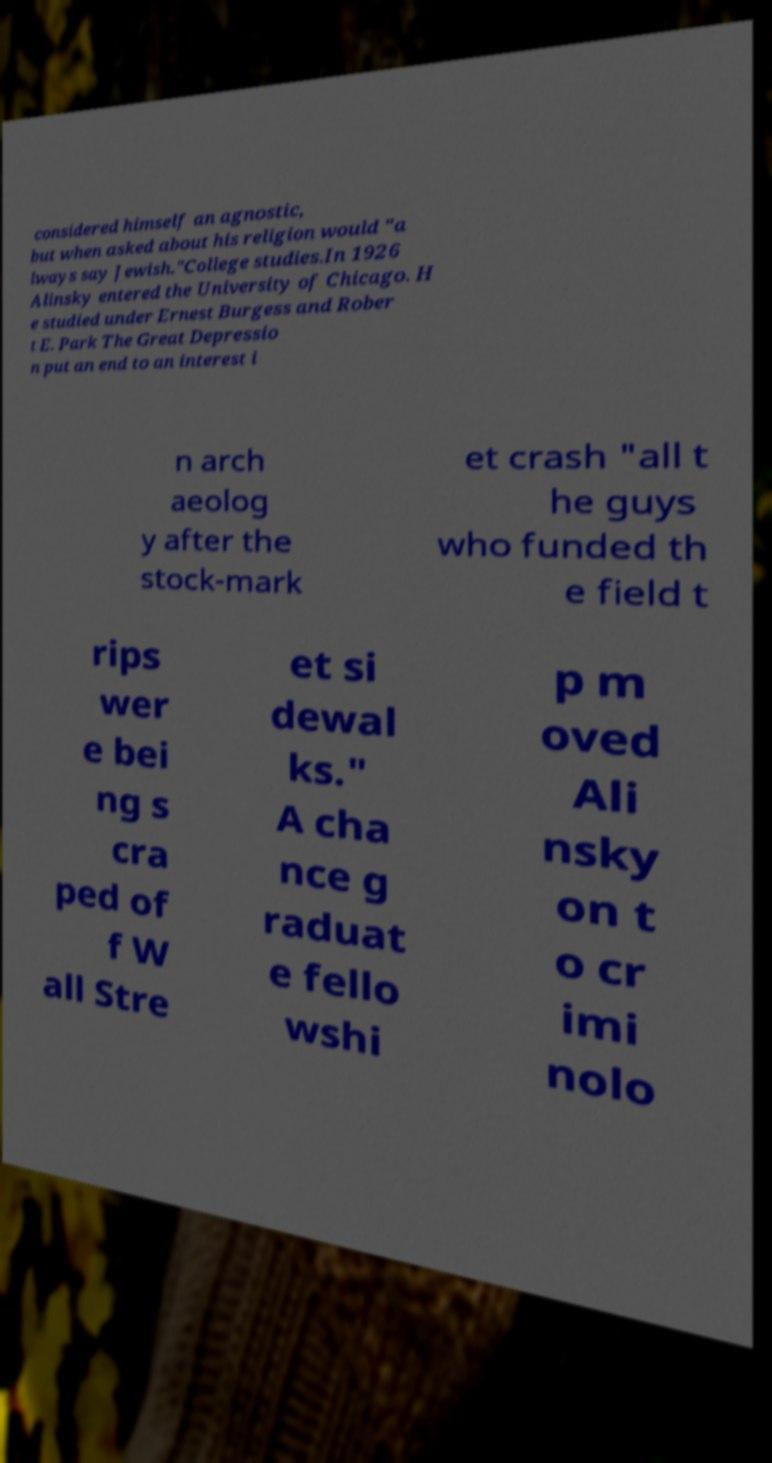Could you assist in decoding the text presented in this image and type it out clearly? considered himself an agnostic, but when asked about his religion would "a lways say Jewish."College studies.In 1926 Alinsky entered the University of Chicago. H e studied under Ernest Burgess and Rober t E. Park The Great Depressio n put an end to an interest i n arch aeolog y after the stock-mark et crash "all t he guys who funded th e field t rips wer e bei ng s cra ped of f W all Stre et si dewal ks." A cha nce g raduat e fello wshi p m oved Ali nsky on t o cr imi nolo 